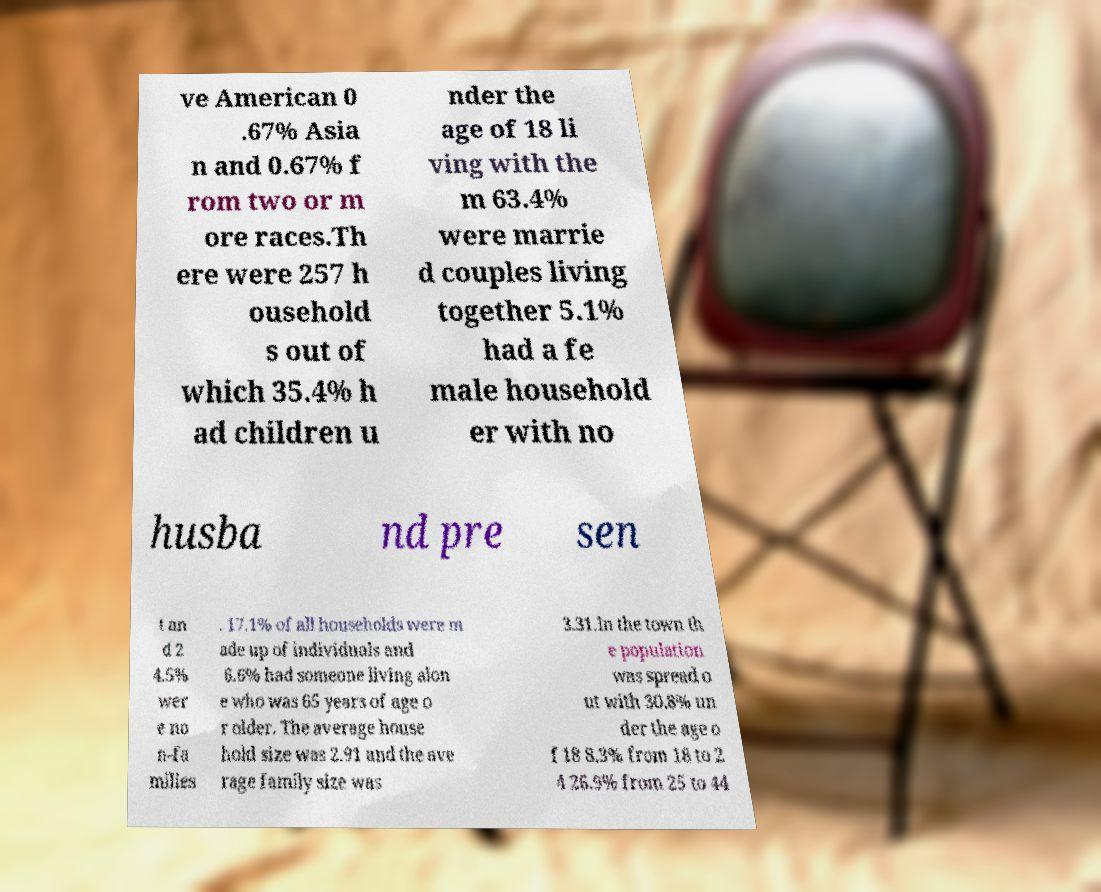I need the written content from this picture converted into text. Can you do that? ve American 0 .67% Asia n and 0.67% f rom two or m ore races.Th ere were 257 h ousehold s out of which 35.4% h ad children u nder the age of 18 li ving with the m 63.4% were marrie d couples living together 5.1% had a fe male household er with no husba nd pre sen t an d 2 4.5% wer e no n-fa milies . 17.1% of all households were m ade up of individuals and 6.6% had someone living alon e who was 65 years of age o r older. The average house hold size was 2.91 and the ave rage family size was 3.31.In the town th e population was spread o ut with 30.8% un der the age o f 18 8.3% from 18 to 2 4 26.9% from 25 to 44 